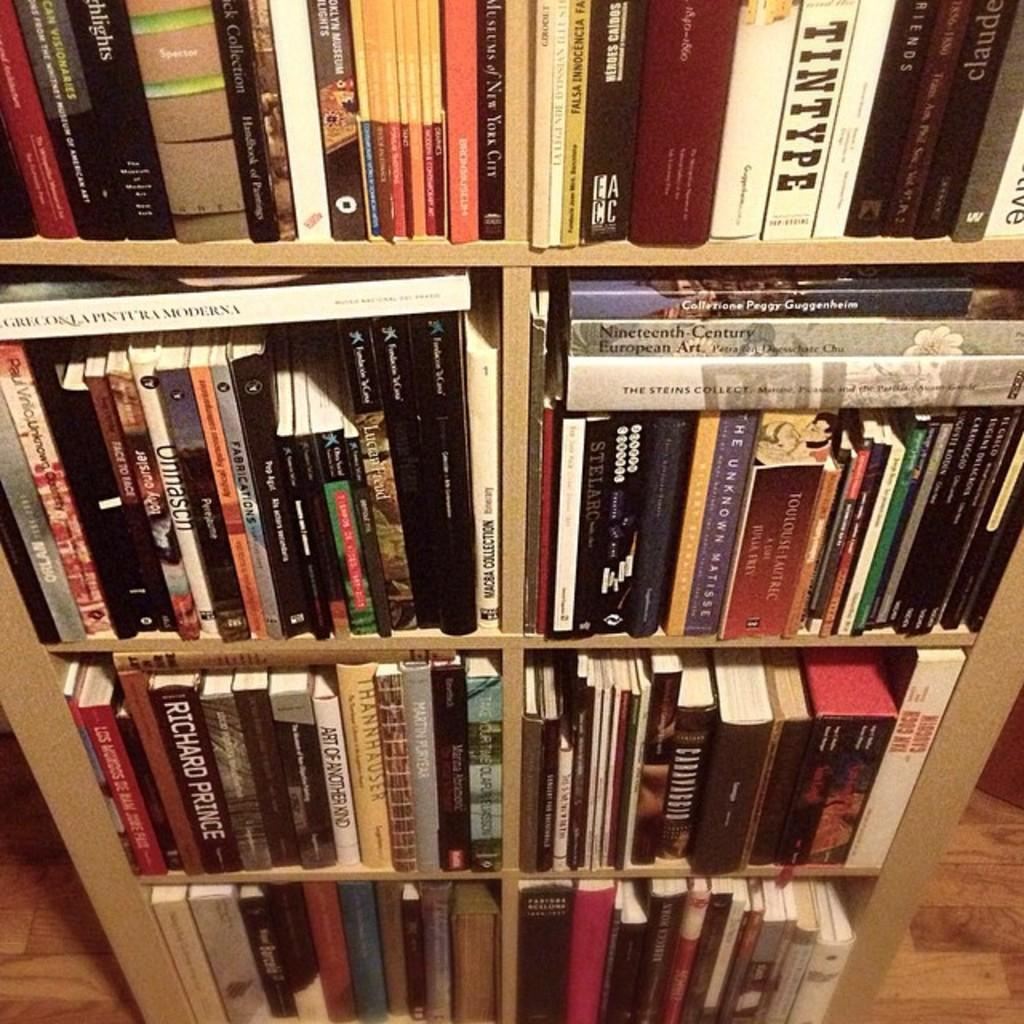<image>
Present a compact description of the photo's key features. A shelf unit full of books, including Art Of Another Kind on the second shelf. 